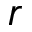<formula> <loc_0><loc_0><loc_500><loc_500>r</formula> 